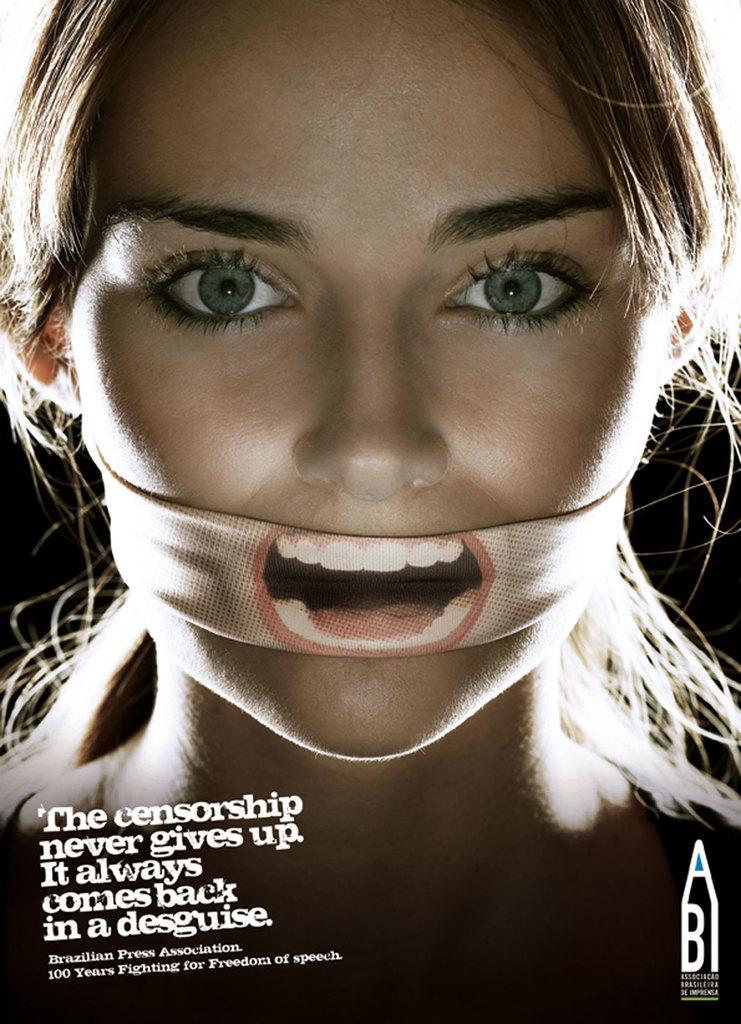Describe this image in one or two sentences. In this image I can see a woman tying her mouth with a cloth and in the left bottom corner I can see some text. 